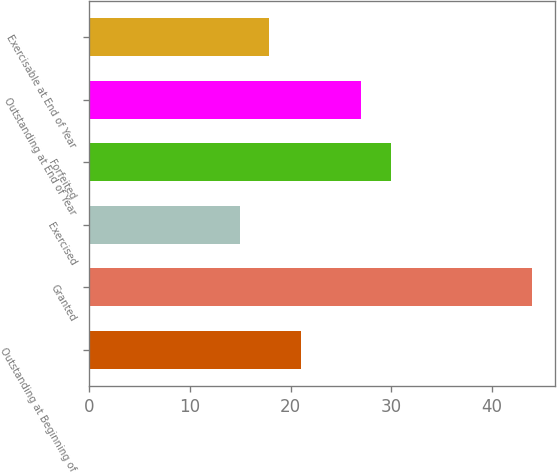Convert chart. <chart><loc_0><loc_0><loc_500><loc_500><bar_chart><fcel>Outstanding at Beginning of<fcel>Granted<fcel>Exercised<fcel>Forfeited<fcel>Outstanding at End of Year<fcel>Exercisable at End of Year<nl><fcel>21<fcel>44<fcel>15<fcel>30<fcel>27<fcel>17.9<nl></chart> 